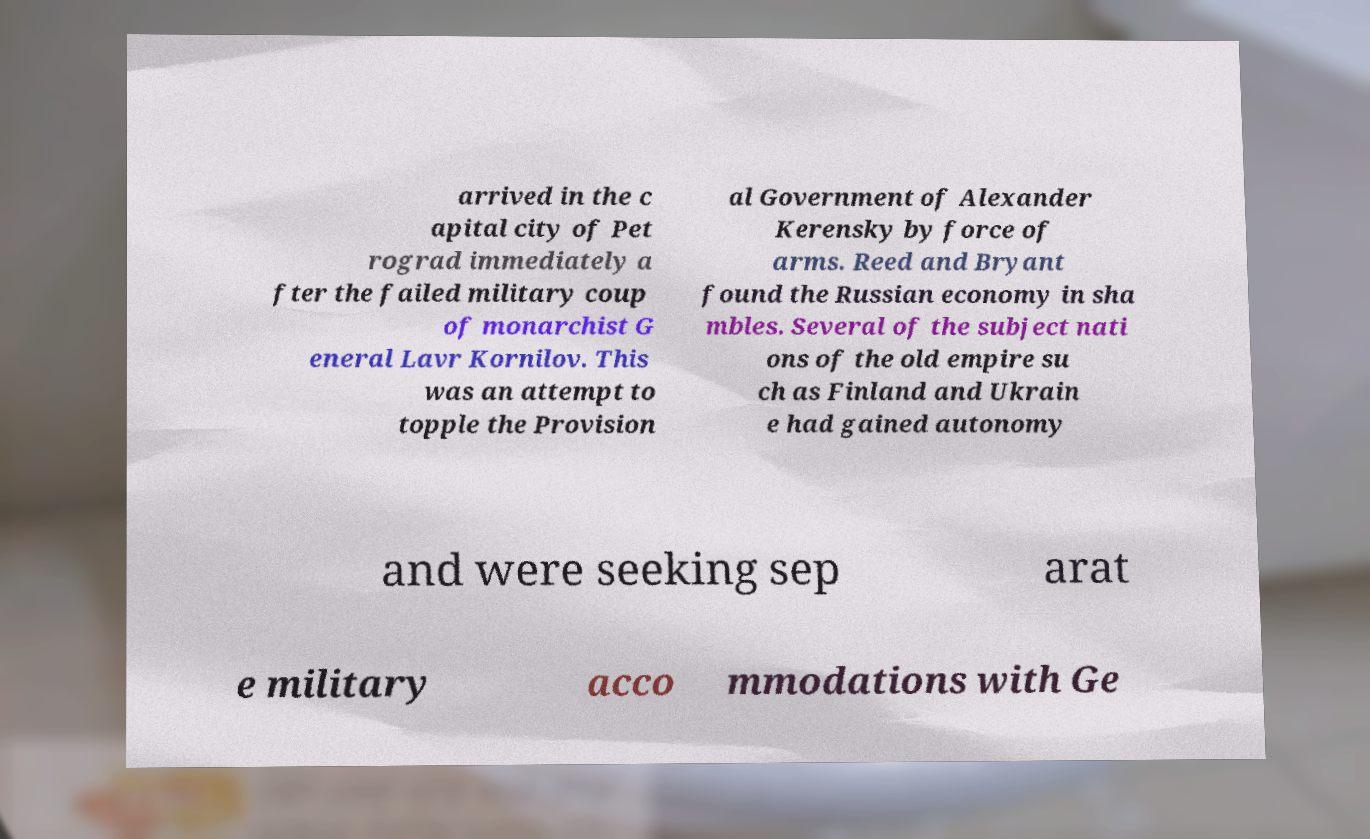Could you extract and type out the text from this image? arrived in the c apital city of Pet rograd immediately a fter the failed military coup of monarchist G eneral Lavr Kornilov. This was an attempt to topple the Provision al Government of Alexander Kerensky by force of arms. Reed and Bryant found the Russian economy in sha mbles. Several of the subject nati ons of the old empire su ch as Finland and Ukrain e had gained autonomy and were seeking sep arat e military acco mmodations with Ge 